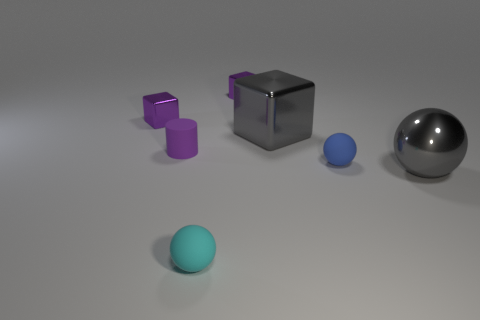What size is the cube that is the same color as the large metallic ball?
Your response must be concise. Large. Is the shape of the tiny blue rubber object the same as the tiny purple object on the right side of the small cyan sphere?
Offer a terse response. No. Is the shiny sphere the same color as the large metallic cube?
Offer a terse response. Yes. There is a metal object behind the tiny purple metallic cube to the left of the small cyan sphere; what shape is it?
Keep it short and to the point. Cube. Are there fewer small cylinders than purple objects?
Provide a succinct answer. Yes. There is a ball that is in front of the blue matte ball and behind the tiny cyan matte object; what size is it?
Give a very brief answer. Large. Do the blue matte thing and the purple cylinder have the same size?
Your answer should be very brief. Yes. There is a big thing that is to the left of the gray shiny sphere; is its color the same as the large shiny ball?
Give a very brief answer. Yes. What number of gray objects are behind the blue matte ball?
Keep it short and to the point. 1. Are there more rubber things than tiny things?
Your response must be concise. No. 